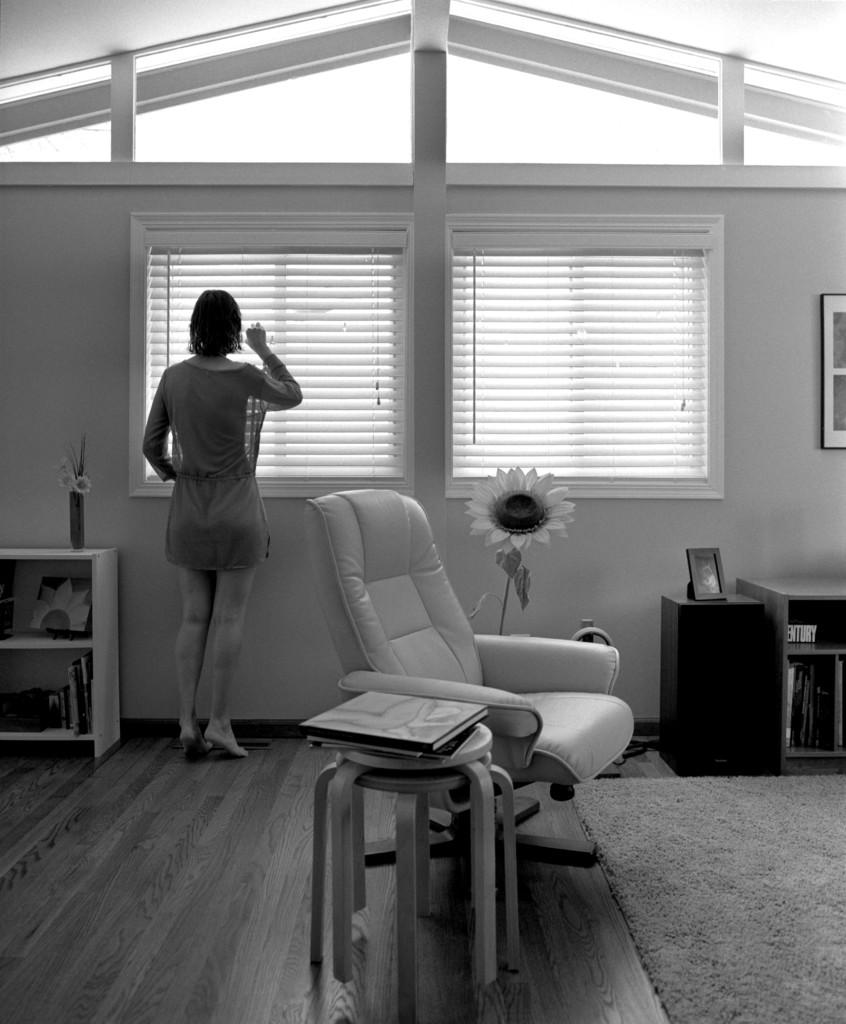What is the main subject of the image? There is a woman standing in the image. What object can be seen near the woman? There is a chair in the image. What item is present on the table in the image? There is a book on the table in the image. What type of window treatment is visible in the image? There are blinds on the window in the image. What kind of plant is featured in the image? There is a plant with a flower in the image. What type of fork can be seen in the image? There is no fork present in the image. Is there any popcorn visible in the image? There is no popcorn present in the image. 